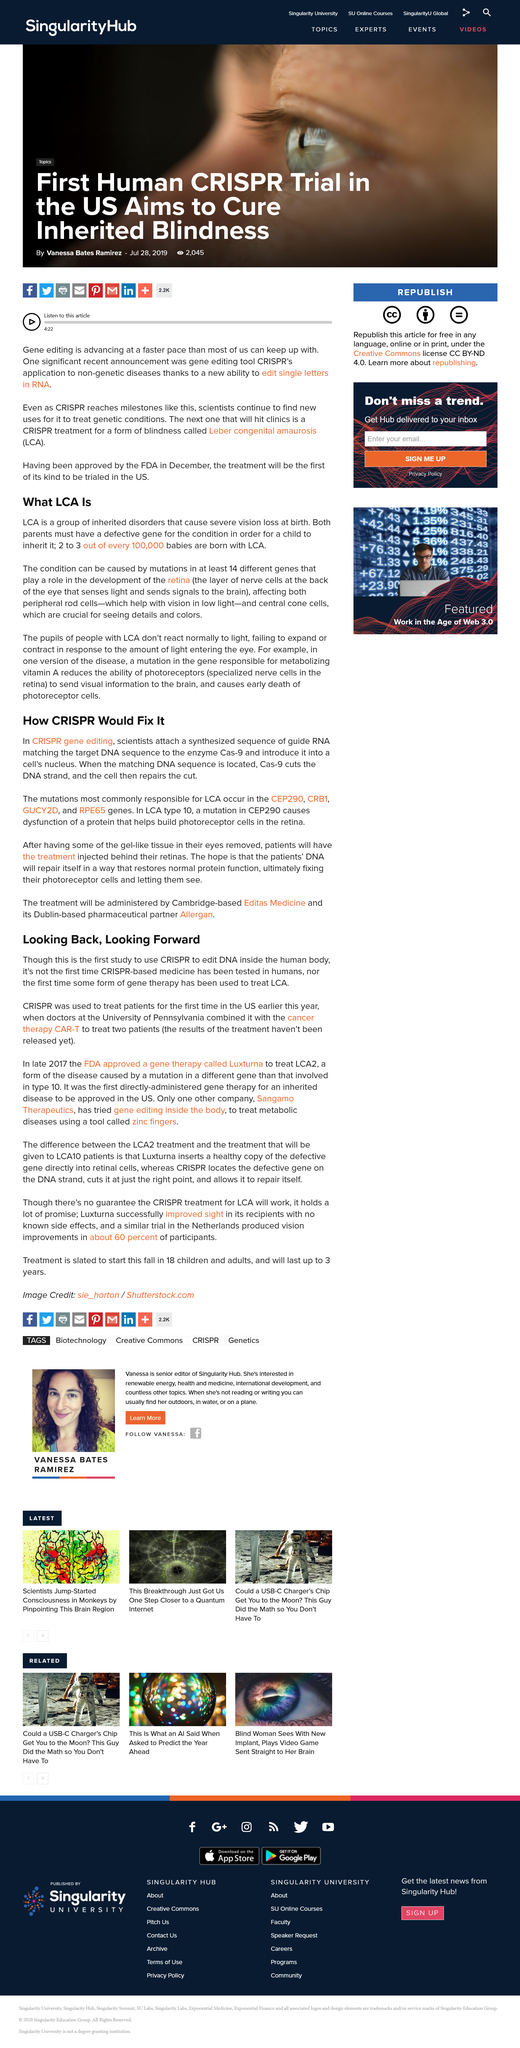Outline some significant characteristics in this image. Mutations in CEP290 CRB1 GUCY2D, and RPE65 are commonly associated with LCA. The title of the document is "How CRISPR Would Fix [Name of Title]. Yes, it has been tested in humans. A person can obtain LCA if both of their parents have a faulty gene that causes the condition, and the child inherits the gene from both parents. During DNA sequencing, the enzyme Cas-9 is often used to cut the DNA strands. What enzyme is the DNA being sequenced to? 